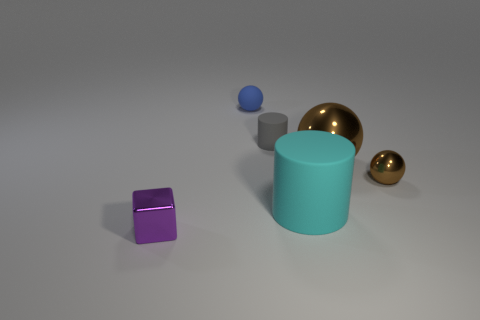Is there any other thing that has the same shape as the purple shiny thing?
Your response must be concise. No. What is the shape of the thing that is on the left side of the large cyan matte cylinder and in front of the tiny brown shiny object?
Offer a terse response. Cube. There is a tiny purple cube on the left side of the sphere to the left of the cyan thing; is there a small thing behind it?
Offer a very short reply. Yes. What number of things are small objects that are behind the metal cube or metallic things to the left of the small brown ball?
Offer a terse response. 5. Are the large thing that is behind the big cyan rubber cylinder and the small cylinder made of the same material?
Your answer should be very brief. No. There is a thing that is both right of the tiny cylinder and to the left of the big brown object; what is its material?
Give a very brief answer. Rubber. There is a small metal object that is in front of the cylinder in front of the small gray cylinder; what color is it?
Provide a short and direct response. Purple. There is another blue thing that is the same shape as the big shiny thing; what material is it?
Your answer should be very brief. Rubber. What is the color of the tiny metal object on the right side of the rubber cylinder behind the tiny sphere that is in front of the small blue object?
Your answer should be very brief. Brown. How many things are tiny things or small purple metal things?
Your answer should be compact. 4. 